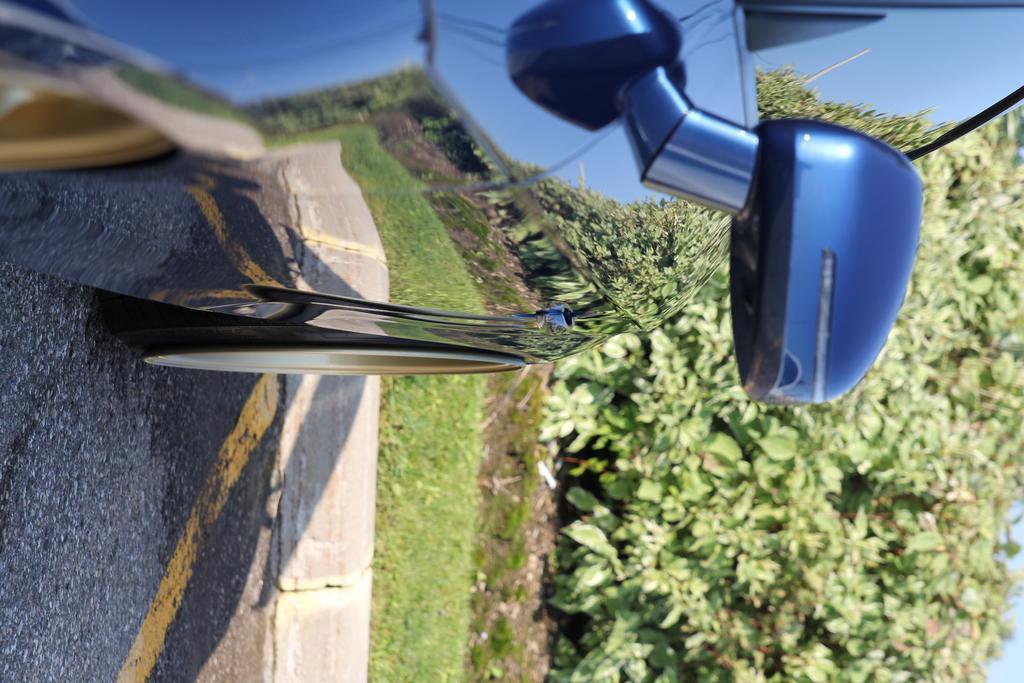In one or two sentences, can you explain what this image depicts? In this image we can see a car on the road, there are plants, also we can see the reflection of plants, poles and the sky on the car. 